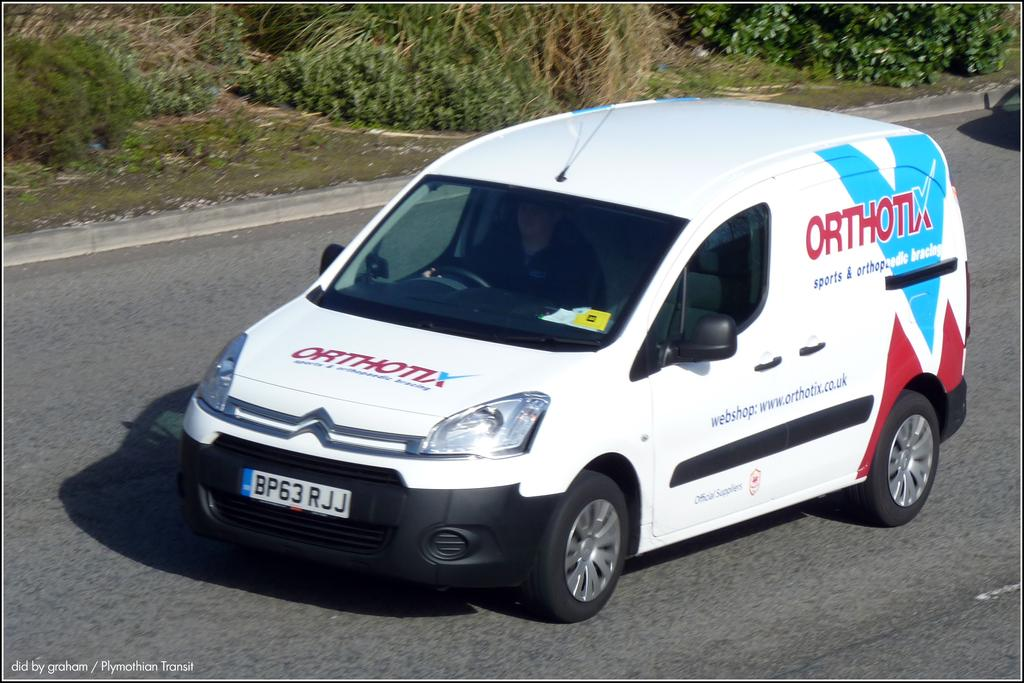<image>
Present a compact description of the photo's key features. A company van has the business name Orthotix on its hood and side. 